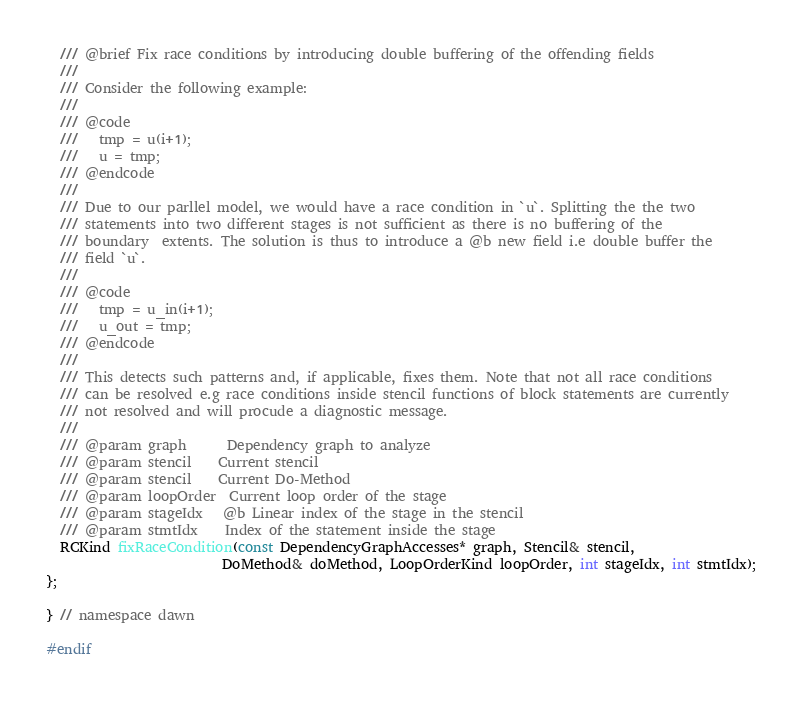Convert code to text. <code><loc_0><loc_0><loc_500><loc_500><_C_>
  /// @brief Fix race conditions by introducing double buffering of the offending fields
  ///
  /// Consider the following example:
  ///
  /// @code
  ///   tmp = u(i+1);
  ///   u = tmp;
  /// @endcode
  ///
  /// Due to our parllel model, we would have a race condition in `u`. Splitting the the two
  /// statements into two different stages is not sufficient as there is no buffering of the
  /// boundary  extents. The solution is thus to introduce a @b new field i.e double buffer the
  /// field `u`.
  ///
  /// @code
  ///   tmp = u_in(i+1);
  ///   u_out = tmp;
  /// @endcode
  ///
  /// This detects such patterns and, if applicable, fixes them. Note that not all race conditions
  /// can be resolved e.g race conditions inside stencil functions of block statements are currently
  /// not resolved and will procude a diagnostic message.
  ///
  /// @param graph      Dependency graph to analyze
  /// @param stencil    Current stencil
  /// @param stencil    Current Do-Method
  /// @param loopOrder  Current loop order of the stage
  /// @param stageIdx   @b Linear index of the stage in the stencil
  /// @param stmtIdx    Index of the statement inside the stage
  RCKind fixRaceCondition(const DependencyGraphAccesses* graph, Stencil& stencil,
                          DoMethod& doMethod, LoopOrderKind loopOrder, int stageIdx, int stmtIdx);
};

} // namespace dawn

#endif
</code> 